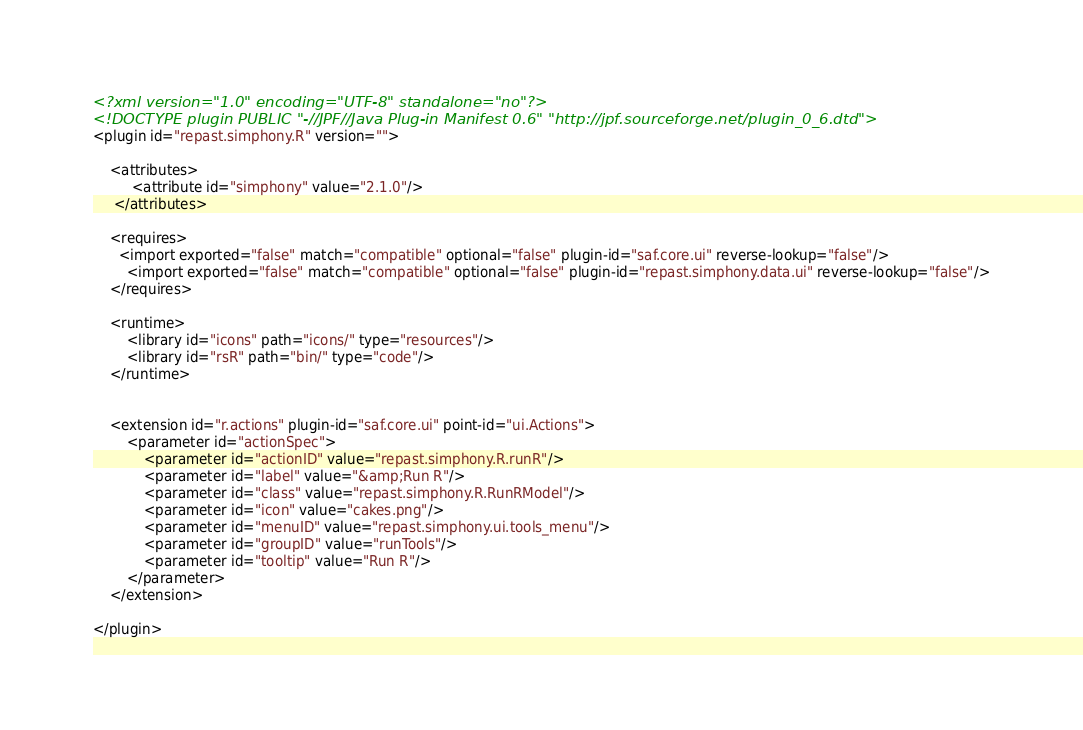Convert code to text. <code><loc_0><loc_0><loc_500><loc_500><_XML_><?xml version="1.0" encoding="UTF-8" standalone="no"?>
<!DOCTYPE plugin PUBLIC "-//JPF//Java Plug-in Manifest 0.6" "http://jpf.sourceforge.net/plugin_0_6.dtd">
<plugin id="repast.simphony.R" version="">
	
	<attributes>
         <attribute id="simphony" value="2.1.0"/>
     </attributes>

	<requires>
	  <import exported="false" match="compatible" optional="false" plugin-id="saf.core.ui" reverse-lookup="false"/>
		<import exported="false" match="compatible" optional="false" plugin-id="repast.simphony.data.ui" reverse-lookup="false"/>
	</requires>

	<runtime>
		<library id="icons" path="icons/" type="resources"/>
		<library id="rsR" path="bin/" type="code"/>
	</runtime>


	<extension id="r.actions" plugin-id="saf.core.ui" point-id="ui.Actions">
		<parameter id="actionSpec">
			<parameter id="actionID" value="repast.simphony.R.runR"/>
			<parameter id="label" value="&amp;Run R"/>
			<parameter id="class" value="repast.simphony.R.RunRModel"/>
			<parameter id="icon" value="cakes.png"/>
			<parameter id="menuID" value="repast.simphony.ui.tools_menu"/>
			<parameter id="groupID" value="runTools"/>
			<parameter id="tooltip" value="Run R"/>
		</parameter>
	</extension>

</plugin>
</code> 